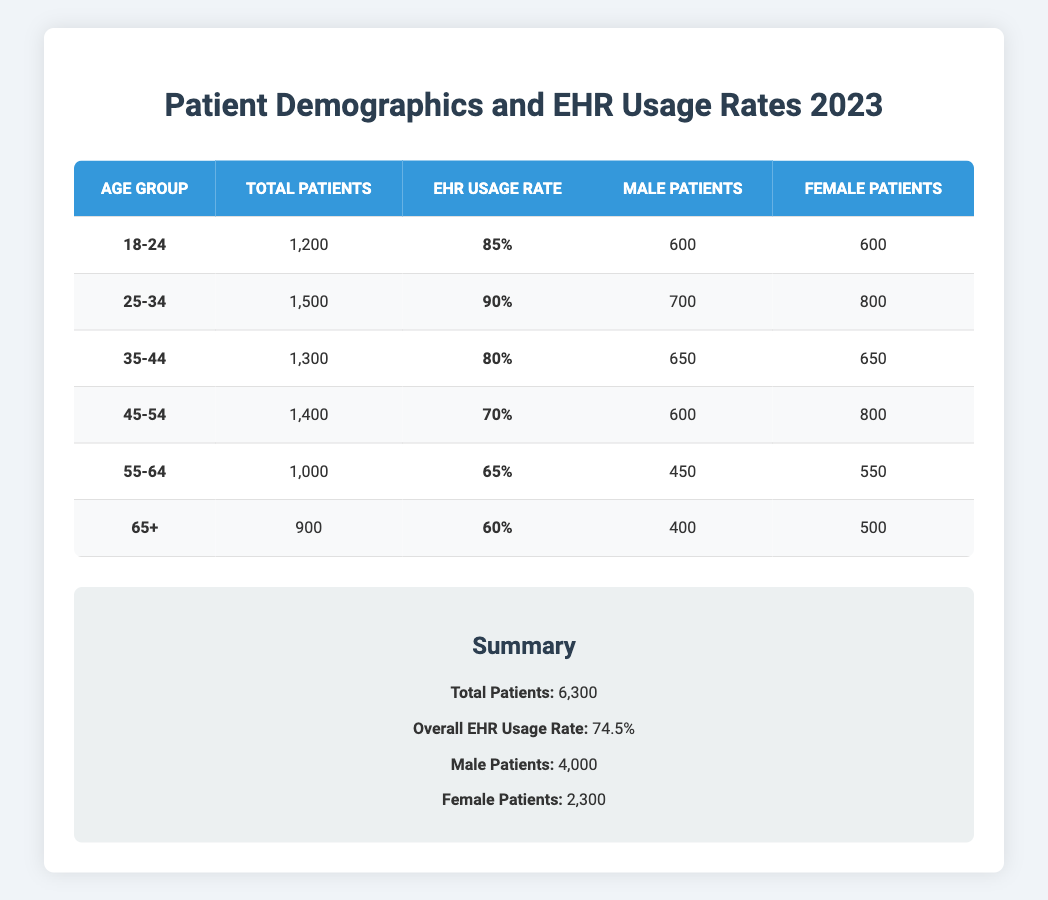What is the EHR usage rate for the 45-54 age group? The usage rate is specifically mentioned in the table for the 45-54 age group as 70%.
Answer: 70% How many total patients are in the age group 25-34? The total number of patients in the age group 25-34 is listed as 1,500 in the table.
Answer: 1,500 What percentage of patients aged 55-64 use the EHR? The EHR usage rate for patients aged 55-64 is given in the table as 65%.
Answer: 65% Which age group has the highest EHR usage rate? By comparing the EHR usage rates, the 25-34 age group stands out with the highest rate of 90%.
Answer: 25-34 How many more male patients are there than female patients in the age group 35-44? In the age group 35-44, there are 650 male patients and 650 female patients; therefore, the difference is 650 - 650 = 0.
Answer: 0 What is the total number of patients in all age groups combined? The total number of patients is summarized at the bottom of the table as 6,300, which represents the sum of all age groups.
Answer: 6,300 Is the overall EHR usage rate above 70%? The overall EHR usage rate is listed in the summary as 74.5%, which is indeed above 70%.
Answer: Yes What is the average EHR usage rate across all age groups? To find the average, we can take the sum of the EHR usage rates (85 + 90 + 80 + 70 + 65 + 60 = 450) and divide it by the number of age groups (6). The average is 450/6 = 75%.
Answer: 75% Which age group has the least number of patients using the EHR? We can see that the 65+ age group has the lowest EHR usage rate at 60%, thus implying it is the least among those listed.
Answer: 65+ What is the total number of male patients across all age groups? By adding the male patient counts from each age group (600 + 700 + 650 + 600 + 450 + 400 = 4000), we confirm that there are 4,000 male patients.
Answer: 4,000 